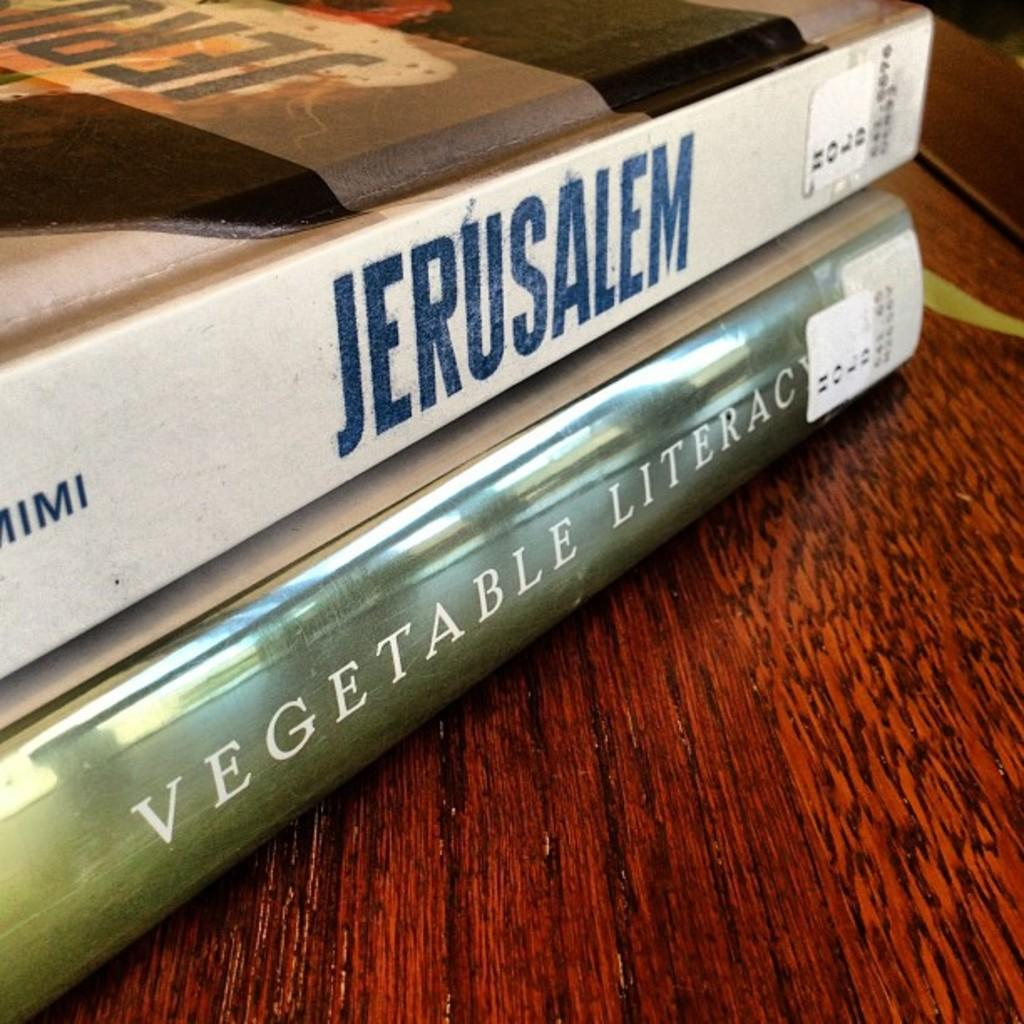<image>
Share a concise interpretation of the image provided. The city mentioned on the top book is Jerusalem. 